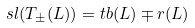Convert formula to latex. <formula><loc_0><loc_0><loc_500><loc_500>s l ( T _ { \pm } ( L ) ) = t b ( L ) \mp r ( L )</formula> 